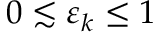Convert formula to latex. <formula><loc_0><loc_0><loc_500><loc_500>0 \lesssim \varepsilon _ { k } \leq 1</formula> 